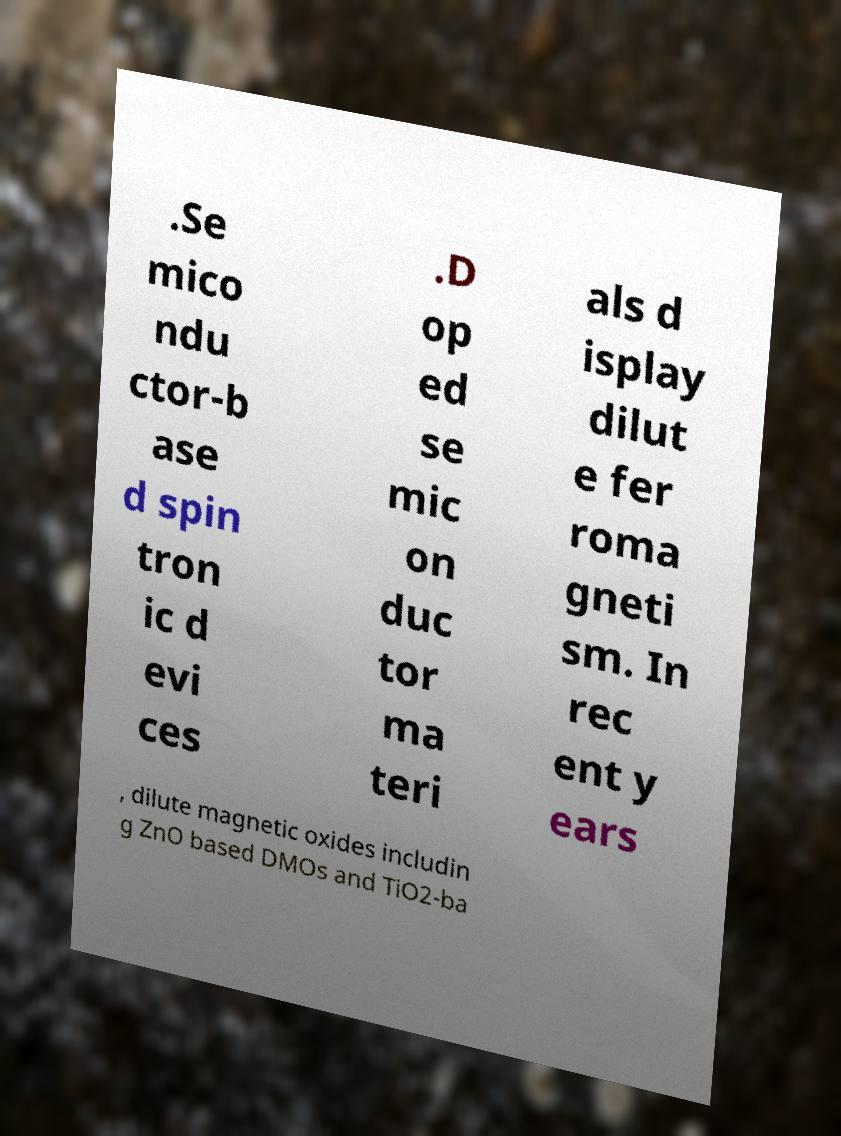Please identify and transcribe the text found in this image. .Se mico ndu ctor-b ase d spin tron ic d evi ces .D op ed se mic on duc tor ma teri als d isplay dilut e fer roma gneti sm. In rec ent y ears , dilute magnetic oxides includin g ZnO based DMOs and TiO2-ba 